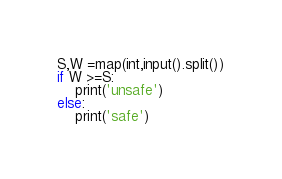<code> <loc_0><loc_0><loc_500><loc_500><_Python_>S,W =map(int,input().split())
if W >=S:
    print('unsafe')
else:
    print('safe')</code> 